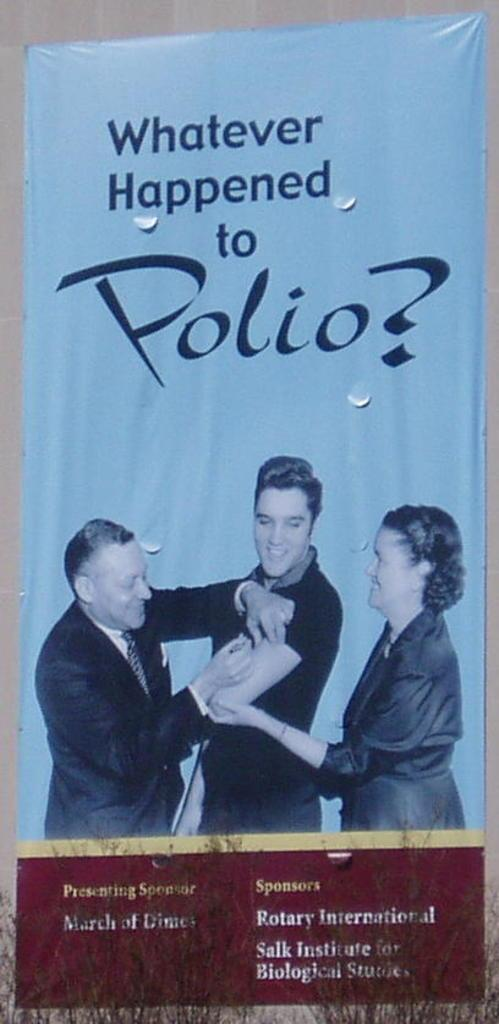<image>
Provide a brief description of the given image. A pamphlet showing Elvis getting a vaccination asks "Whatever Happened to Polio?" 